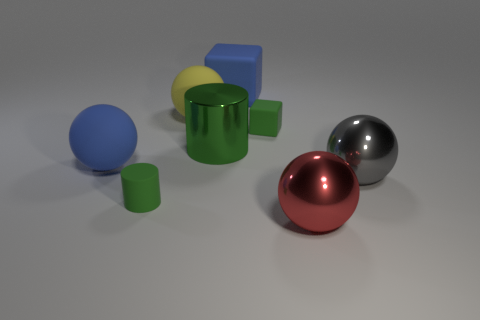Do the tiny matte cylinder and the cylinder behind the gray ball have the same color?
Offer a very short reply. Yes. There is a matte cube that is on the right side of the big matte cube; is its color the same as the big shiny cylinder?
Provide a short and direct response. Yes. Are there any matte balls that have the same size as the gray metallic sphere?
Ensure brevity in your answer.  Yes. There is a green rubber object that is behind the tiny green thing that is left of the big yellow matte object; what size is it?
Keep it short and to the point. Small. Is the number of red shiny balls in front of the large gray sphere less than the number of green objects?
Your answer should be compact. Yes. Do the shiny cylinder and the tiny rubber block have the same color?
Provide a succinct answer. Yes. The green matte cylinder has what size?
Provide a succinct answer. Small. How many tiny objects are the same color as the shiny cylinder?
Make the answer very short. 2. Are there any large yellow rubber things that are behind the large rubber cube that is right of the metal object that is left of the blue matte block?
Keep it short and to the point. No. What shape is the green object that is the same size as the blue matte ball?
Offer a terse response. Cylinder. 